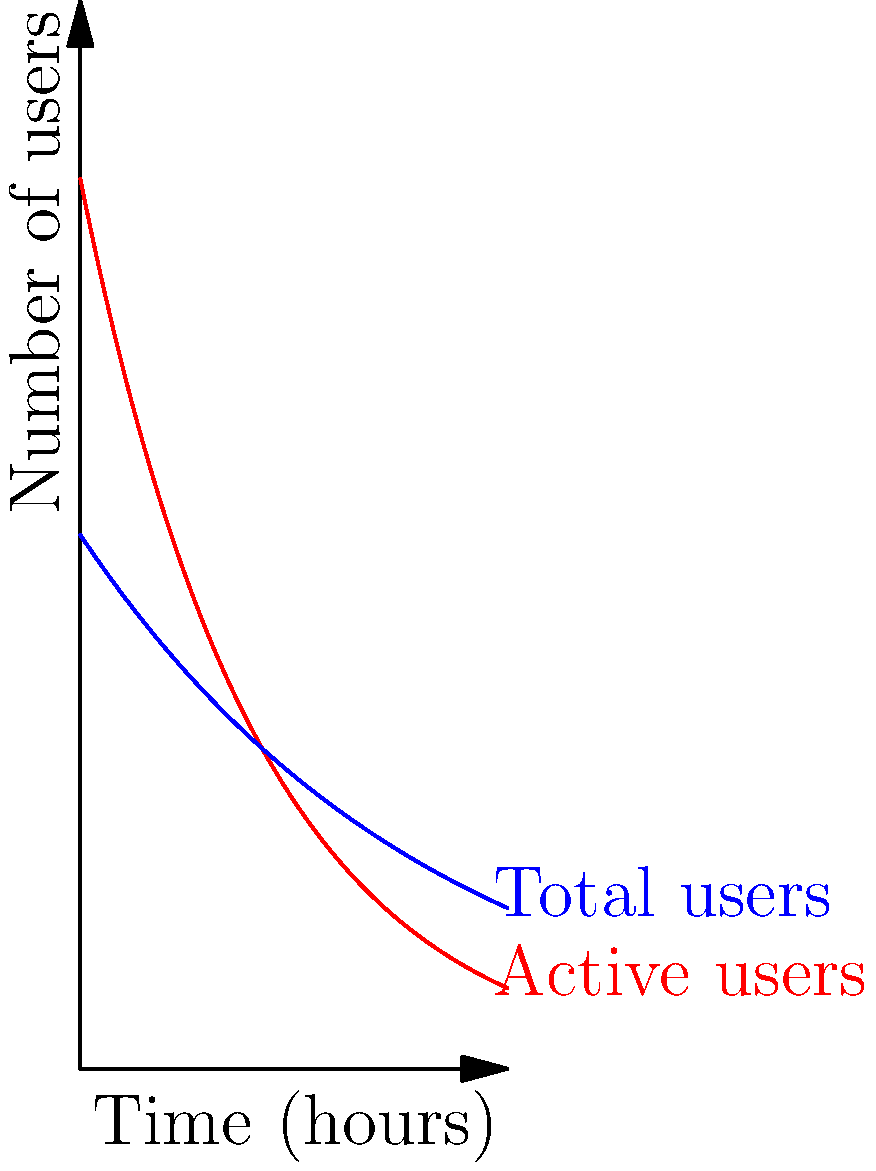As a bot analyzing user persona based on forum activity, you need to calculate the total time spent by users on the forum over a 24-hour period. The graph shows the number of active users (red curve) and total users (blue curve) over time. The total time spent is represented by the area between these two curves. Calculate this area using integration.

Given:
- Active users function: $f(t) = 50e^{-0.1t}$
- Total users function: $g(t) = 30e^{-0.05t}$
- Time period: 0 to 24 hours

Find the total user-hours spent on the forum in this 24-hour period. To solve this problem, we need to follow these steps:

1) The area between the curves represents the difference between total users and active users, integrated over time.

2) Set up the integral:
   $\int_{0}^{24} [g(t) - f(t)] dt$

3) Substitute the functions:
   $\int_{0}^{24} [30e^{-0.05t} - 50e^{-0.1t}] dt$

4) Integrate:
   $[-600e^{-0.05t} + 500e^{-0.1t}]_{0}^{24}$

5) Evaluate the integral:
   $(-600e^{-0.05(24)} + 500e^{-0.1(24)}) - (-600 + 500)$
   
   $= (-600 \cdot 0.3012 + 500 \cdot 0.0907) - (-100)$
   
   $= (-180.72 + 45.35) + 100$
   
   $= -35.37 + 100 = 64.63$

6) Round to two decimal places:
   64.63 user-hours
Answer: 64.63 user-hours 